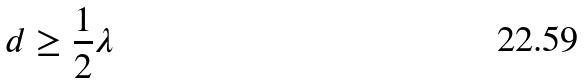Convert formula to latex. <formula><loc_0><loc_0><loc_500><loc_500>d \geq \frac { 1 } { 2 } \lambda</formula> 